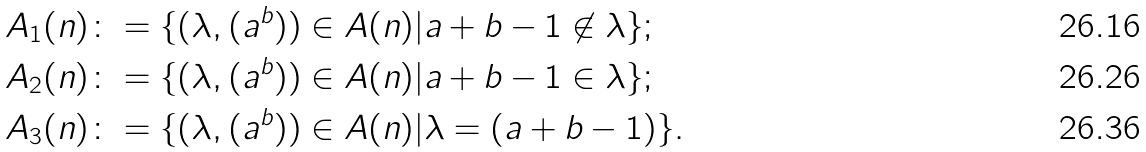Convert formula to latex. <formula><loc_0><loc_0><loc_500><loc_500>& A _ { 1 } ( n ) \colon = \{ ( \lambda , ( a ^ { b } ) ) \in A ( n ) | a + b - 1 \not \in \lambda \} ; \\ & A _ { 2 } ( n ) \colon = \{ ( \lambda , ( a ^ { b } ) ) \in A ( n ) | a + b - 1 \in \lambda \} ; \\ & A _ { 3 } ( n ) \colon = \{ ( \lambda , ( a ^ { b } ) ) \in A ( n ) | \lambda = ( a + b - 1 ) \} .</formula> 